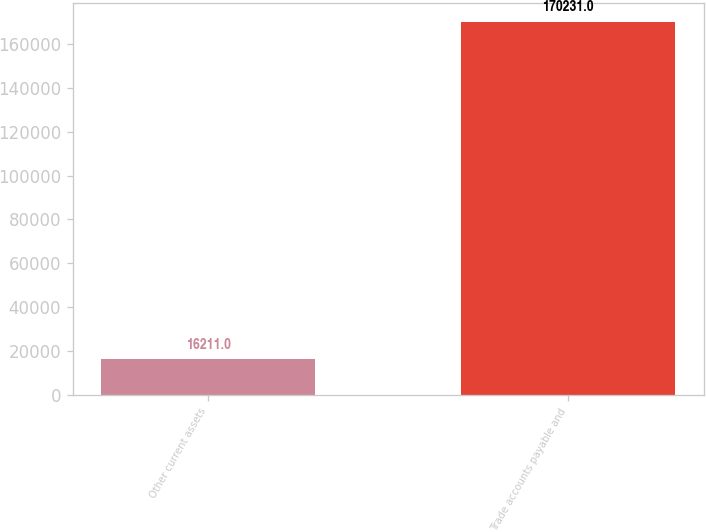Convert chart to OTSL. <chart><loc_0><loc_0><loc_500><loc_500><bar_chart><fcel>Other current assets<fcel>Trade accounts payable and<nl><fcel>16211<fcel>170231<nl></chart> 